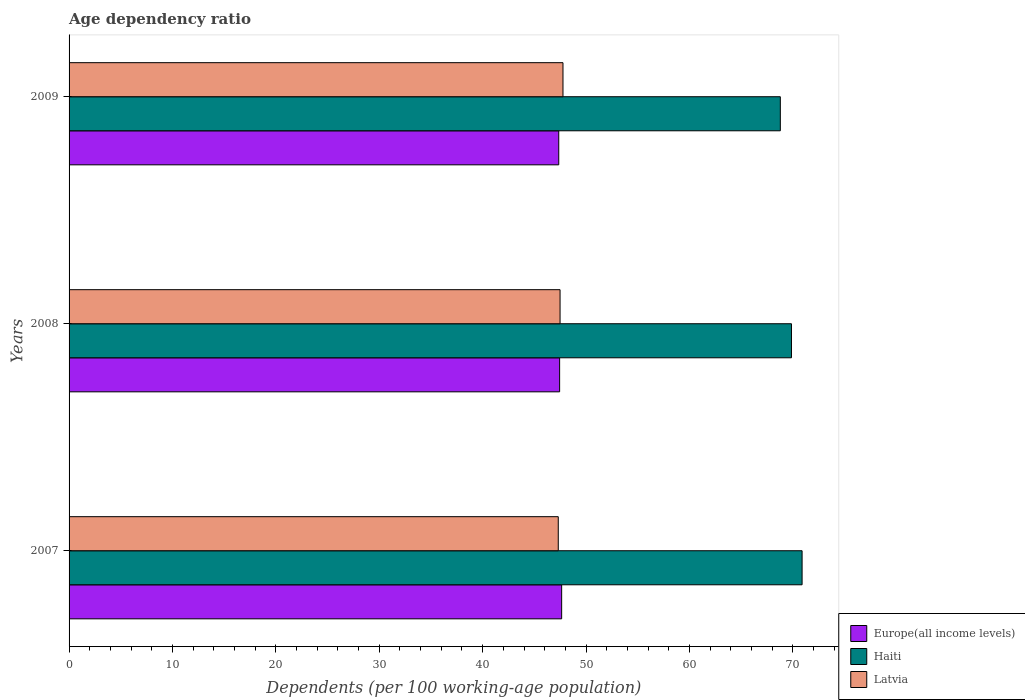How many groups of bars are there?
Your answer should be very brief. 3. Are the number of bars per tick equal to the number of legend labels?
Provide a succinct answer. Yes. How many bars are there on the 3rd tick from the top?
Offer a very short reply. 3. What is the label of the 1st group of bars from the top?
Provide a succinct answer. 2009. In how many cases, is the number of bars for a given year not equal to the number of legend labels?
Your answer should be compact. 0. What is the age dependency ratio in in Latvia in 2009?
Your response must be concise. 47.77. Across all years, what is the maximum age dependency ratio in in Latvia?
Ensure brevity in your answer.  47.77. Across all years, what is the minimum age dependency ratio in in Latvia?
Ensure brevity in your answer.  47.31. In which year was the age dependency ratio in in Europe(all income levels) maximum?
Your response must be concise. 2007. What is the total age dependency ratio in in Latvia in the graph?
Ensure brevity in your answer.  142.56. What is the difference between the age dependency ratio in in Haiti in 2007 and that in 2008?
Provide a succinct answer. 1.03. What is the difference between the age dependency ratio in in Europe(all income levels) in 2009 and the age dependency ratio in in Haiti in 2007?
Offer a very short reply. -23.53. What is the average age dependency ratio in in Haiti per year?
Offer a very short reply. 69.85. In the year 2009, what is the difference between the age dependency ratio in in Haiti and age dependency ratio in in Latvia?
Offer a very short reply. 21.02. In how many years, is the age dependency ratio in in Europe(all income levels) greater than 46 %?
Give a very brief answer. 3. What is the ratio of the age dependency ratio in in Europe(all income levels) in 2008 to that in 2009?
Offer a very short reply. 1. Is the age dependency ratio in in Europe(all income levels) in 2008 less than that in 2009?
Keep it short and to the point. No. Is the difference between the age dependency ratio in in Haiti in 2007 and 2009 greater than the difference between the age dependency ratio in in Latvia in 2007 and 2009?
Give a very brief answer. Yes. What is the difference between the highest and the second highest age dependency ratio in in Latvia?
Ensure brevity in your answer.  0.28. What is the difference between the highest and the lowest age dependency ratio in in Latvia?
Offer a terse response. 0.46. In how many years, is the age dependency ratio in in Latvia greater than the average age dependency ratio in in Latvia taken over all years?
Your response must be concise. 1. What does the 2nd bar from the top in 2008 represents?
Ensure brevity in your answer.  Haiti. What does the 1st bar from the bottom in 2008 represents?
Your answer should be compact. Europe(all income levels). How many bars are there?
Ensure brevity in your answer.  9. Are all the bars in the graph horizontal?
Your answer should be compact. Yes. How many years are there in the graph?
Make the answer very short. 3. Does the graph contain any zero values?
Keep it short and to the point. No. Does the graph contain grids?
Give a very brief answer. No. Where does the legend appear in the graph?
Offer a very short reply. Bottom right. What is the title of the graph?
Give a very brief answer. Age dependency ratio. What is the label or title of the X-axis?
Ensure brevity in your answer.  Dependents (per 100 working-age population). What is the label or title of the Y-axis?
Offer a very short reply. Years. What is the Dependents (per 100 working-age population) in Europe(all income levels) in 2007?
Ensure brevity in your answer.  47.64. What is the Dependents (per 100 working-age population) in Haiti in 2007?
Offer a very short reply. 70.89. What is the Dependents (per 100 working-age population) in Latvia in 2007?
Offer a very short reply. 47.31. What is the Dependents (per 100 working-age population) in Europe(all income levels) in 2008?
Give a very brief answer. 47.44. What is the Dependents (per 100 working-age population) in Haiti in 2008?
Make the answer very short. 69.87. What is the Dependents (per 100 working-age population) in Latvia in 2008?
Keep it short and to the point. 47.48. What is the Dependents (per 100 working-age population) in Europe(all income levels) in 2009?
Make the answer very short. 47.36. What is the Dependents (per 100 working-age population) in Haiti in 2009?
Offer a very short reply. 68.79. What is the Dependents (per 100 working-age population) in Latvia in 2009?
Ensure brevity in your answer.  47.77. Across all years, what is the maximum Dependents (per 100 working-age population) in Europe(all income levels)?
Provide a succinct answer. 47.64. Across all years, what is the maximum Dependents (per 100 working-age population) of Haiti?
Give a very brief answer. 70.89. Across all years, what is the maximum Dependents (per 100 working-age population) in Latvia?
Offer a very short reply. 47.77. Across all years, what is the minimum Dependents (per 100 working-age population) of Europe(all income levels)?
Make the answer very short. 47.36. Across all years, what is the minimum Dependents (per 100 working-age population) in Haiti?
Ensure brevity in your answer.  68.79. Across all years, what is the minimum Dependents (per 100 working-age population) of Latvia?
Offer a terse response. 47.31. What is the total Dependents (per 100 working-age population) in Europe(all income levels) in the graph?
Your response must be concise. 142.44. What is the total Dependents (per 100 working-age population) in Haiti in the graph?
Your response must be concise. 209.54. What is the total Dependents (per 100 working-age population) of Latvia in the graph?
Your answer should be very brief. 142.56. What is the difference between the Dependents (per 100 working-age population) of Europe(all income levels) in 2007 and that in 2008?
Your answer should be compact. 0.2. What is the difference between the Dependents (per 100 working-age population) of Haiti in 2007 and that in 2008?
Ensure brevity in your answer.  1.03. What is the difference between the Dependents (per 100 working-age population) of Latvia in 2007 and that in 2008?
Make the answer very short. -0.17. What is the difference between the Dependents (per 100 working-age population) of Europe(all income levels) in 2007 and that in 2009?
Ensure brevity in your answer.  0.28. What is the difference between the Dependents (per 100 working-age population) in Haiti in 2007 and that in 2009?
Your response must be concise. 2.11. What is the difference between the Dependents (per 100 working-age population) of Latvia in 2007 and that in 2009?
Ensure brevity in your answer.  -0.46. What is the difference between the Dependents (per 100 working-age population) in Europe(all income levels) in 2008 and that in 2009?
Provide a succinct answer. 0.08. What is the difference between the Dependents (per 100 working-age population) in Haiti in 2008 and that in 2009?
Make the answer very short. 1.08. What is the difference between the Dependents (per 100 working-age population) in Latvia in 2008 and that in 2009?
Offer a very short reply. -0.28. What is the difference between the Dependents (per 100 working-age population) in Europe(all income levels) in 2007 and the Dependents (per 100 working-age population) in Haiti in 2008?
Provide a short and direct response. -22.23. What is the difference between the Dependents (per 100 working-age population) of Europe(all income levels) in 2007 and the Dependents (per 100 working-age population) of Latvia in 2008?
Offer a very short reply. 0.15. What is the difference between the Dependents (per 100 working-age population) of Haiti in 2007 and the Dependents (per 100 working-age population) of Latvia in 2008?
Provide a succinct answer. 23.41. What is the difference between the Dependents (per 100 working-age population) in Europe(all income levels) in 2007 and the Dependents (per 100 working-age population) in Haiti in 2009?
Your answer should be compact. -21.15. What is the difference between the Dependents (per 100 working-age population) in Europe(all income levels) in 2007 and the Dependents (per 100 working-age population) in Latvia in 2009?
Make the answer very short. -0.13. What is the difference between the Dependents (per 100 working-age population) of Haiti in 2007 and the Dependents (per 100 working-age population) of Latvia in 2009?
Offer a very short reply. 23.12. What is the difference between the Dependents (per 100 working-age population) of Europe(all income levels) in 2008 and the Dependents (per 100 working-age population) of Haiti in 2009?
Make the answer very short. -21.34. What is the difference between the Dependents (per 100 working-age population) in Europe(all income levels) in 2008 and the Dependents (per 100 working-age population) in Latvia in 2009?
Offer a very short reply. -0.33. What is the difference between the Dependents (per 100 working-age population) of Haiti in 2008 and the Dependents (per 100 working-age population) of Latvia in 2009?
Make the answer very short. 22.1. What is the average Dependents (per 100 working-age population) in Europe(all income levels) per year?
Your answer should be compact. 47.48. What is the average Dependents (per 100 working-age population) of Haiti per year?
Provide a succinct answer. 69.85. What is the average Dependents (per 100 working-age population) of Latvia per year?
Your answer should be compact. 47.52. In the year 2007, what is the difference between the Dependents (per 100 working-age population) of Europe(all income levels) and Dependents (per 100 working-age population) of Haiti?
Keep it short and to the point. -23.25. In the year 2007, what is the difference between the Dependents (per 100 working-age population) in Europe(all income levels) and Dependents (per 100 working-age population) in Latvia?
Give a very brief answer. 0.33. In the year 2007, what is the difference between the Dependents (per 100 working-age population) in Haiti and Dependents (per 100 working-age population) in Latvia?
Provide a short and direct response. 23.58. In the year 2008, what is the difference between the Dependents (per 100 working-age population) in Europe(all income levels) and Dependents (per 100 working-age population) in Haiti?
Offer a terse response. -22.42. In the year 2008, what is the difference between the Dependents (per 100 working-age population) in Europe(all income levels) and Dependents (per 100 working-age population) in Latvia?
Ensure brevity in your answer.  -0.04. In the year 2008, what is the difference between the Dependents (per 100 working-age population) of Haiti and Dependents (per 100 working-age population) of Latvia?
Your answer should be very brief. 22.38. In the year 2009, what is the difference between the Dependents (per 100 working-age population) of Europe(all income levels) and Dependents (per 100 working-age population) of Haiti?
Your answer should be compact. -21.43. In the year 2009, what is the difference between the Dependents (per 100 working-age population) of Europe(all income levels) and Dependents (per 100 working-age population) of Latvia?
Provide a short and direct response. -0.41. In the year 2009, what is the difference between the Dependents (per 100 working-age population) in Haiti and Dependents (per 100 working-age population) in Latvia?
Give a very brief answer. 21.02. What is the ratio of the Dependents (per 100 working-age population) of Europe(all income levels) in 2007 to that in 2008?
Give a very brief answer. 1. What is the ratio of the Dependents (per 100 working-age population) in Haiti in 2007 to that in 2008?
Keep it short and to the point. 1.01. What is the ratio of the Dependents (per 100 working-age population) of Latvia in 2007 to that in 2008?
Keep it short and to the point. 1. What is the ratio of the Dependents (per 100 working-age population) of Europe(all income levels) in 2007 to that in 2009?
Your answer should be very brief. 1.01. What is the ratio of the Dependents (per 100 working-age population) in Haiti in 2007 to that in 2009?
Your answer should be very brief. 1.03. What is the ratio of the Dependents (per 100 working-age population) of Europe(all income levels) in 2008 to that in 2009?
Your answer should be compact. 1. What is the ratio of the Dependents (per 100 working-age population) of Haiti in 2008 to that in 2009?
Your response must be concise. 1.02. What is the difference between the highest and the second highest Dependents (per 100 working-age population) in Europe(all income levels)?
Offer a terse response. 0.2. What is the difference between the highest and the second highest Dependents (per 100 working-age population) of Haiti?
Make the answer very short. 1.03. What is the difference between the highest and the second highest Dependents (per 100 working-age population) in Latvia?
Your answer should be very brief. 0.28. What is the difference between the highest and the lowest Dependents (per 100 working-age population) in Europe(all income levels)?
Keep it short and to the point. 0.28. What is the difference between the highest and the lowest Dependents (per 100 working-age population) in Haiti?
Your answer should be compact. 2.11. What is the difference between the highest and the lowest Dependents (per 100 working-age population) in Latvia?
Your response must be concise. 0.46. 